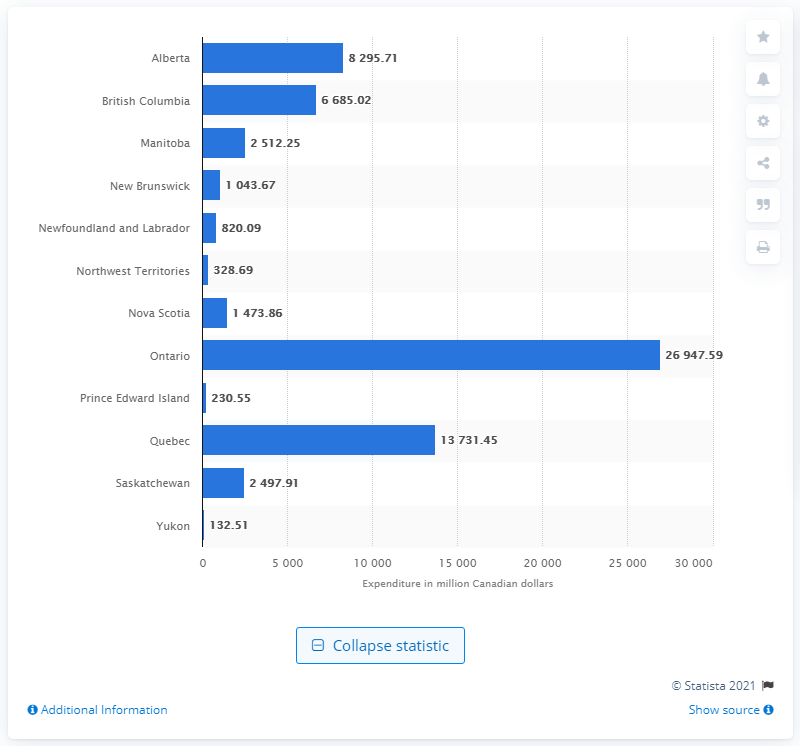Give some essential details in this illustration. Ontario's highest expenditure was 26,947.59. The total expenditure of the school boards in the Yukon province of Canada by the end of 2017 was $132.51. 